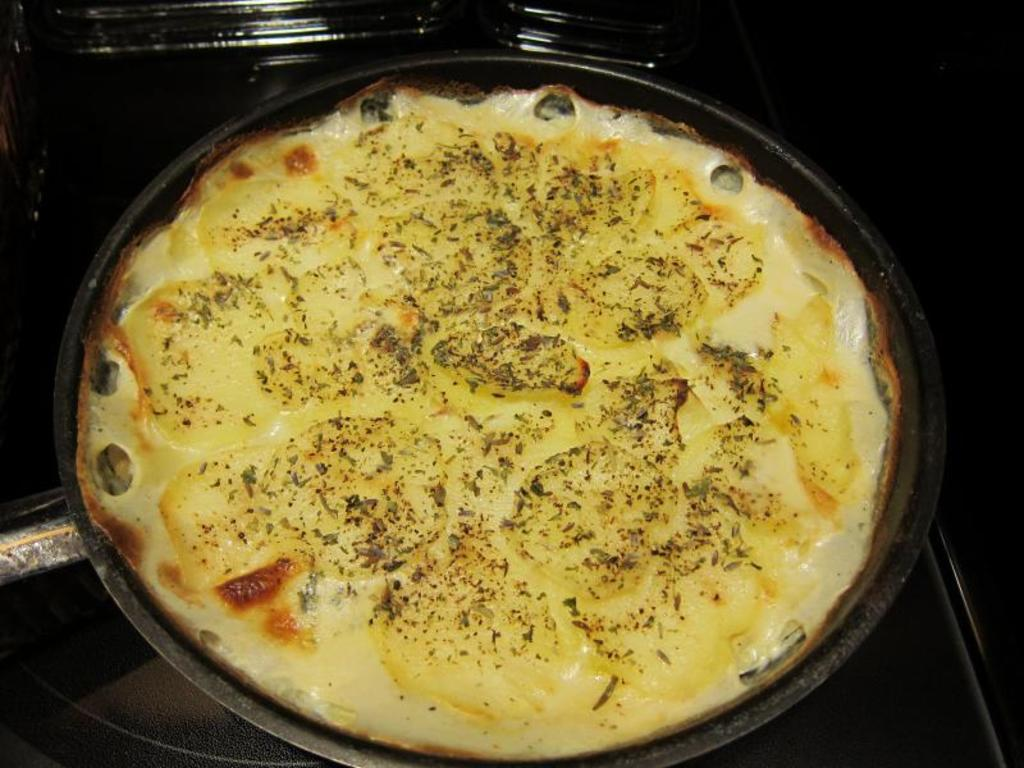What is in the pan that is visible in the image? There is a food item in the pan in the image. Can you describe the objects in the background of the image? Unfortunately, the provided facts do not give enough information to describe the objects in the background of the image. How many apples are on the sidewalk in the image? There are no apples or sidewalks present in the image. 